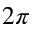Convert formula to latex. <formula><loc_0><loc_0><loc_500><loc_500>2 \pi</formula> 